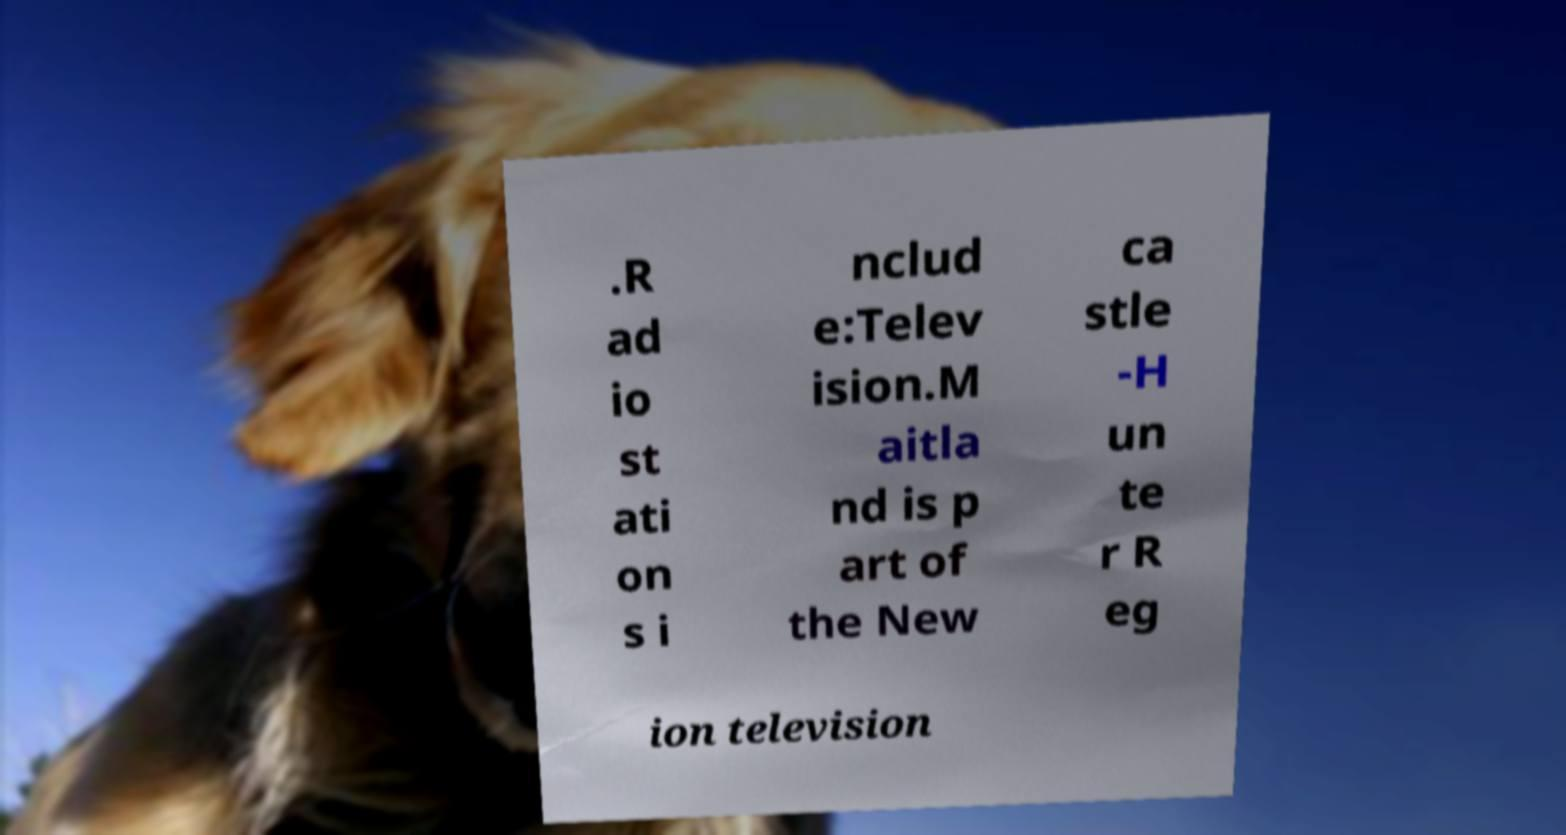Could you assist in decoding the text presented in this image and type it out clearly? .R ad io st ati on s i nclud e:Telev ision.M aitla nd is p art of the New ca stle -H un te r R eg ion television 